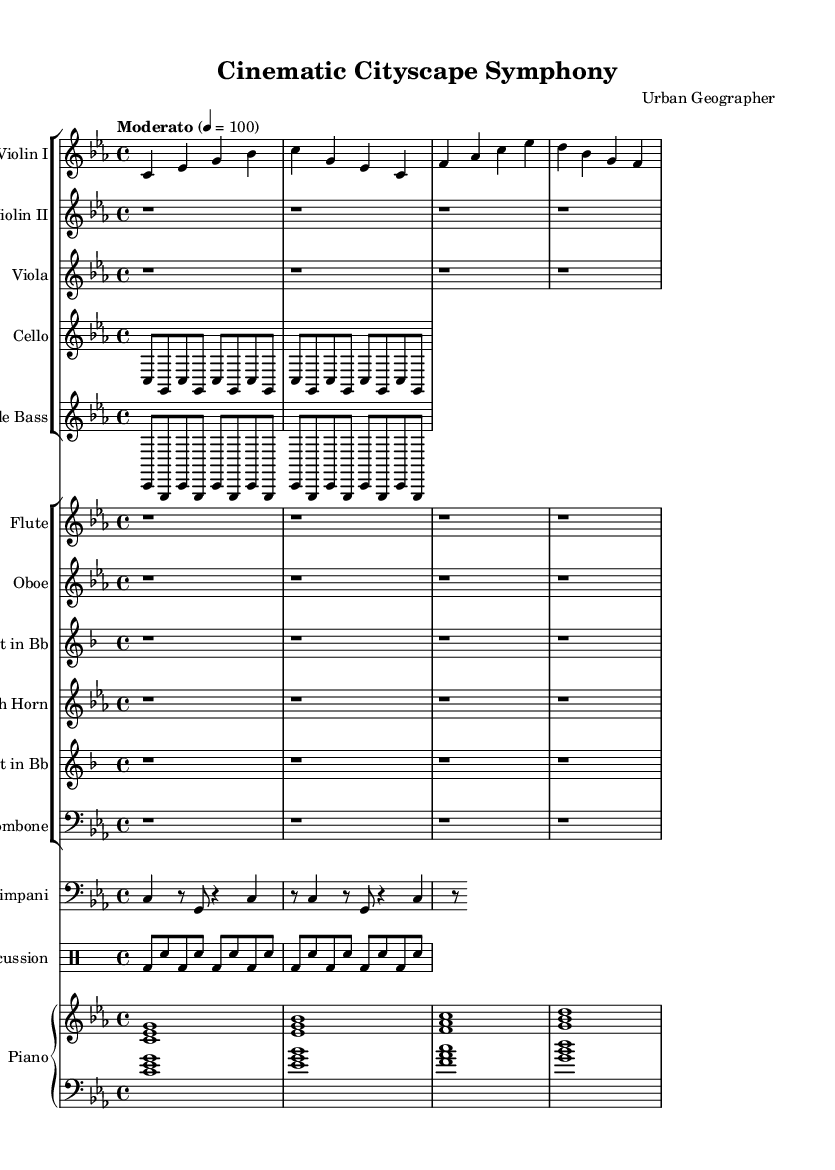What is the key signature of this music? The key signature is C minor, which has three flats (B flat, E flat, and A flat).
Answer: C minor What is the time signature of this music? The time signature displayed at the beginning is 4/4, indicating four beats per measure with a quarter note getting one beat.
Answer: 4/4 What is the tempo marking indicated in this music? The tempo marking is "Moderato," which suggests a moderate pace, typically around 100 beats per minute.
Answer: Moderato How many measures are in the violin one part? The violin one part contains a total of four measures as counted from the beginning to the end of the provided music.
Answer: Four measures What instruments are included in the symphony? The symphony includes String instruments like Violin I, Violin II, Viola, Cello, Double Bass, Woodwinds such as Flute, Oboe, Clarinet, French Horn, Trumpet, and Trombone, along with Timpani and Percussion.
Answer: Strings, Woodwinds, Timpani, Percussion Which instrument plays sustained rhythmic notes in the introduction? The piano plays sustained rhythmic notes, marked by the whole chords that create a stable harmonic foundation.
Answer: Piano What is the role of the percussion part in this symphony? The percussion part uses a consistent pattern, creating a rhythmic drive that supports the overall texture of the piece.
Answer: Rhythmic drive 